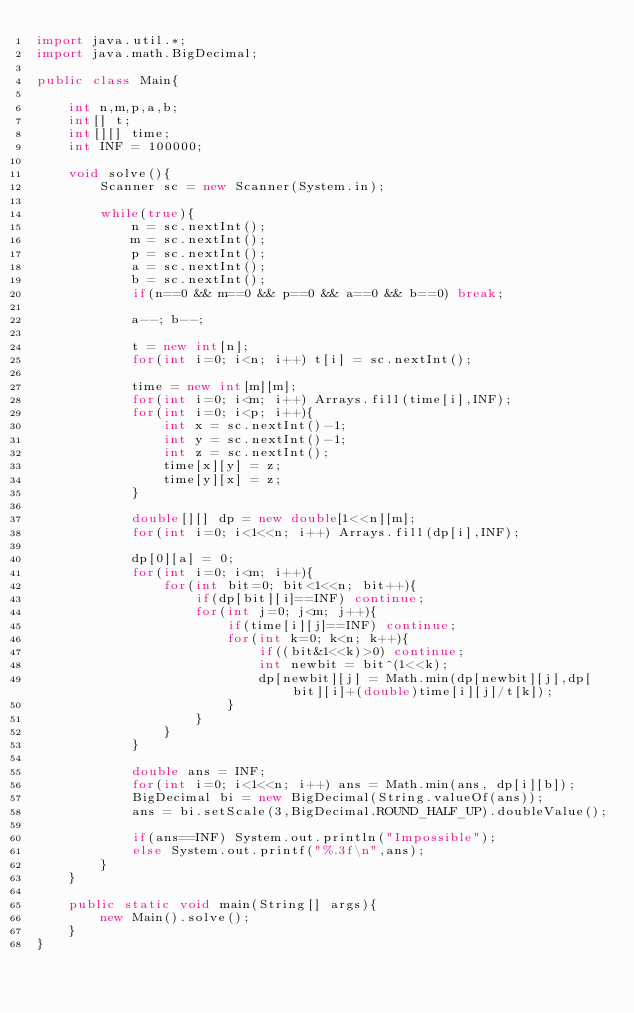<code> <loc_0><loc_0><loc_500><loc_500><_Java_>import java.util.*;
import java.math.BigDecimal;

public class Main{

    int n,m,p,a,b;
    int[] t;
    int[][] time;
    int INF = 100000;

    void solve(){
        Scanner sc = new Scanner(System.in);

        while(true){
            n = sc.nextInt();
            m = sc.nextInt();
            p = sc.nextInt();
            a = sc.nextInt();
            b = sc.nextInt();
            if(n==0 && m==0 && p==0 && a==0 && b==0) break;

            a--; b--;

            t = new int[n];
            for(int i=0; i<n; i++) t[i] = sc.nextInt();

            time = new int[m][m];
            for(int i=0; i<m; i++) Arrays.fill(time[i],INF);
            for(int i=0; i<p; i++){
                int x = sc.nextInt()-1;
                int y = sc.nextInt()-1;
                int z = sc.nextInt();
                time[x][y] = z;
                time[y][x] = z;
            }

            double[][] dp = new double[1<<n][m];
            for(int i=0; i<1<<n; i++) Arrays.fill(dp[i],INF);

            dp[0][a] = 0;
            for(int i=0; i<m; i++){
                for(int bit=0; bit<1<<n; bit++){
                    if(dp[bit][i]==INF) continue;
                    for(int j=0; j<m; j++){
                        if(time[i][j]==INF) continue;
                        for(int k=0; k<n; k++){
                            if((bit&1<<k)>0) continue;
                            int newbit = bit^(1<<k);
                            dp[newbit][j] = Math.min(dp[newbit][j],dp[bit][i]+(double)time[i][j]/t[k]);
                        }
                    }
                }
            }

            double ans = INF;
            for(int i=0; i<1<<n; i++) ans = Math.min(ans, dp[i][b]);
            BigDecimal bi = new BigDecimal(String.valueOf(ans));
            ans = bi.setScale(3,BigDecimal.ROUND_HALF_UP).doubleValue();

            if(ans==INF) System.out.println("Impossible");
            else System.out.printf("%.3f\n",ans);
        }
    }

    public static void main(String[] args){
        new Main().solve();
    }
}</code> 